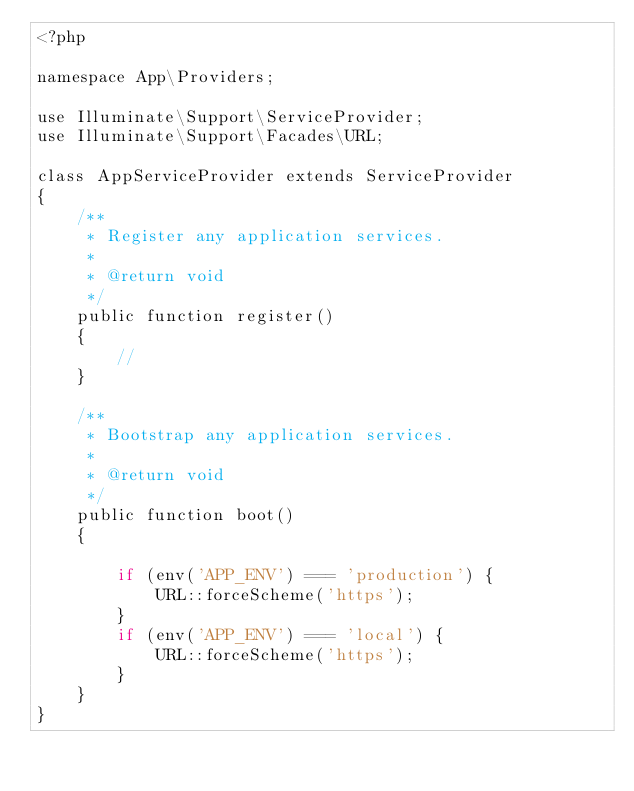Convert code to text. <code><loc_0><loc_0><loc_500><loc_500><_PHP_><?php

namespace App\Providers;

use Illuminate\Support\ServiceProvider;
use Illuminate\Support\Facades\URL;

class AppServiceProvider extends ServiceProvider
{
    /**
     * Register any application services.
     *
     * @return void
     */
    public function register()
    {
        //
    }

    /**
     * Bootstrap any application services.
     *
     * @return void
     */
    public function boot()
    {

        if (env('APP_ENV') === 'production') {
            URL::forceScheme('https');
        }
        if (env('APP_ENV') === 'local') {
            URL::forceScheme('https');
        }
    }
}
</code> 